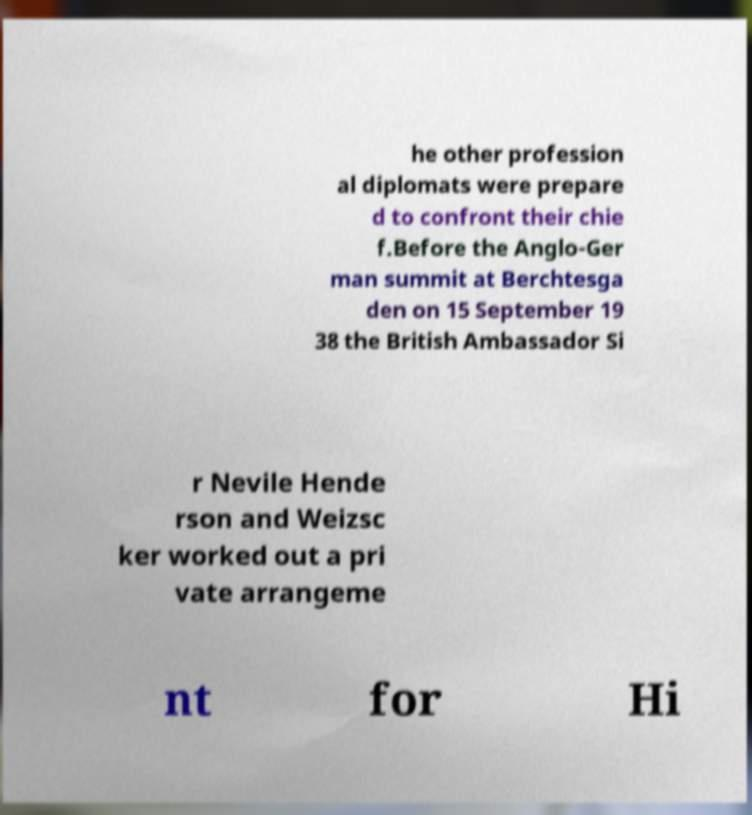What messages or text are displayed in this image? I need them in a readable, typed format. he other profession al diplomats were prepare d to confront their chie f.Before the Anglo-Ger man summit at Berchtesga den on 15 September 19 38 the British Ambassador Si r Nevile Hende rson and Weizsc ker worked out a pri vate arrangeme nt for Hi 